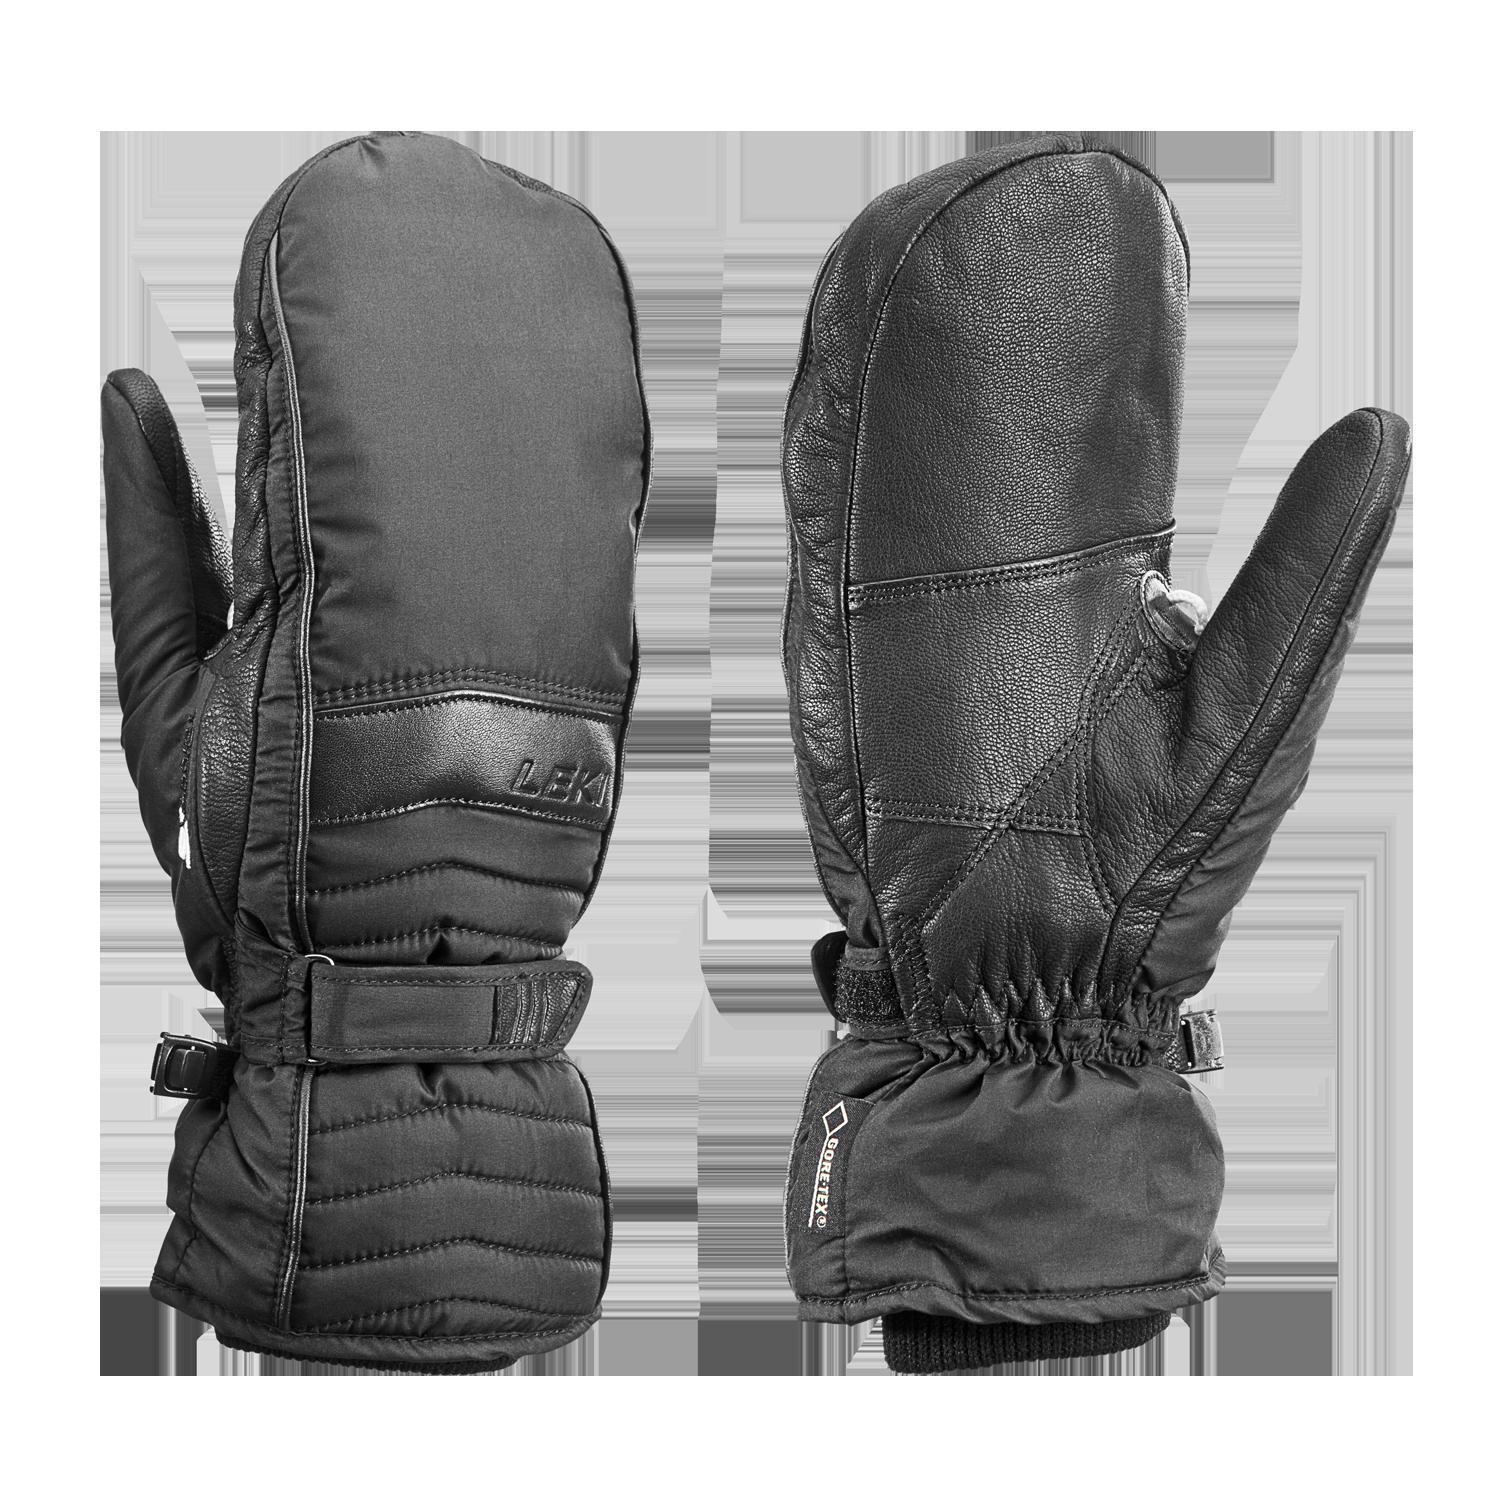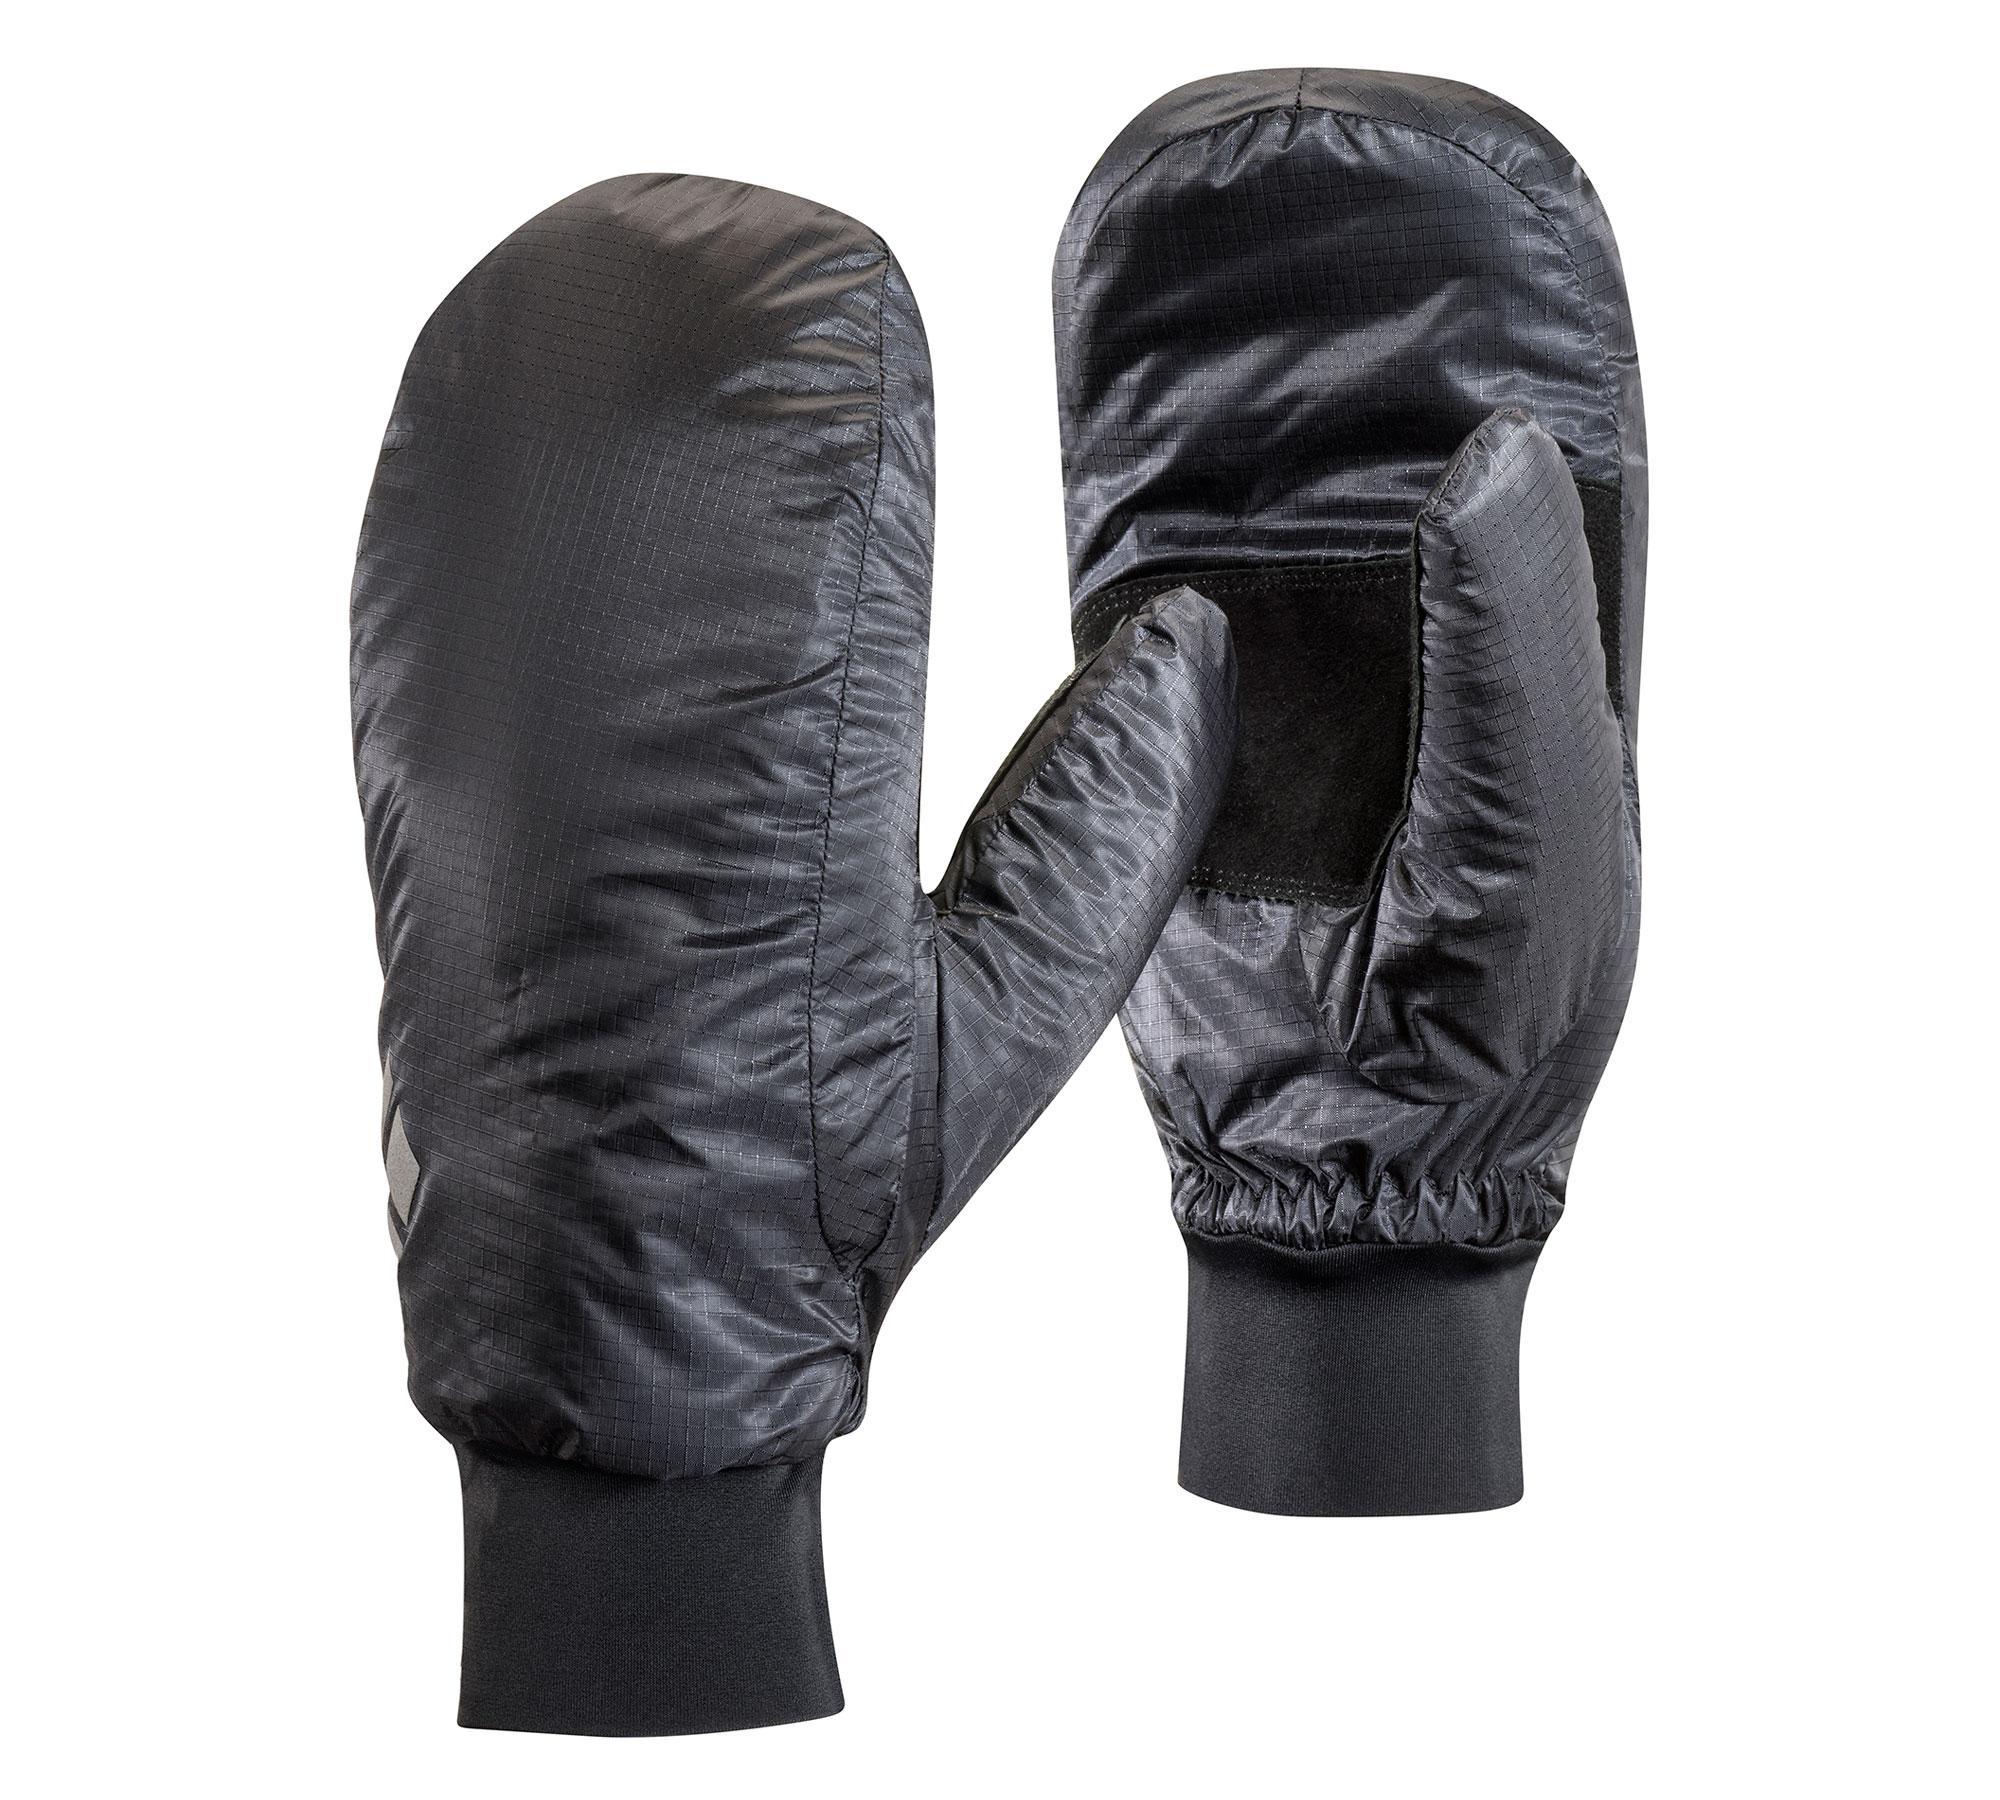The first image is the image on the left, the second image is the image on the right. For the images displayed, is the sentence "Each image shows the front and back of a pair of black mittens with no individual fingers, and no pair of mittens has overlapping individual mittens." factually correct? Answer yes or no. No. The first image is the image on the left, the second image is the image on the right. For the images shown, is this caption "There is a matching set of right and left hand gloves." true? Answer yes or no. Yes. 